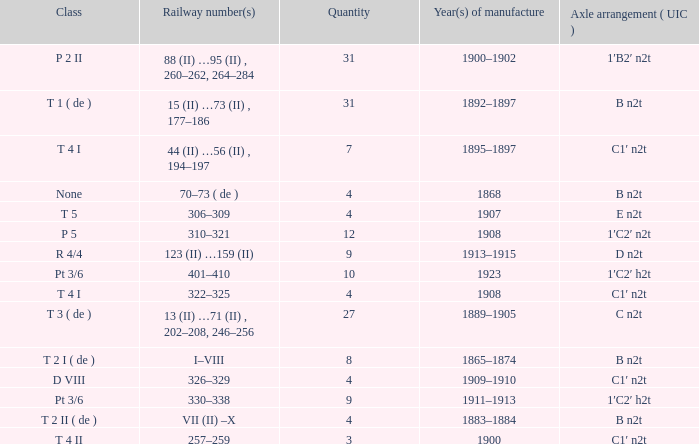What year was the b n2t axle arrangement, which has a quantity of 31, manufactured? 1892–1897. 